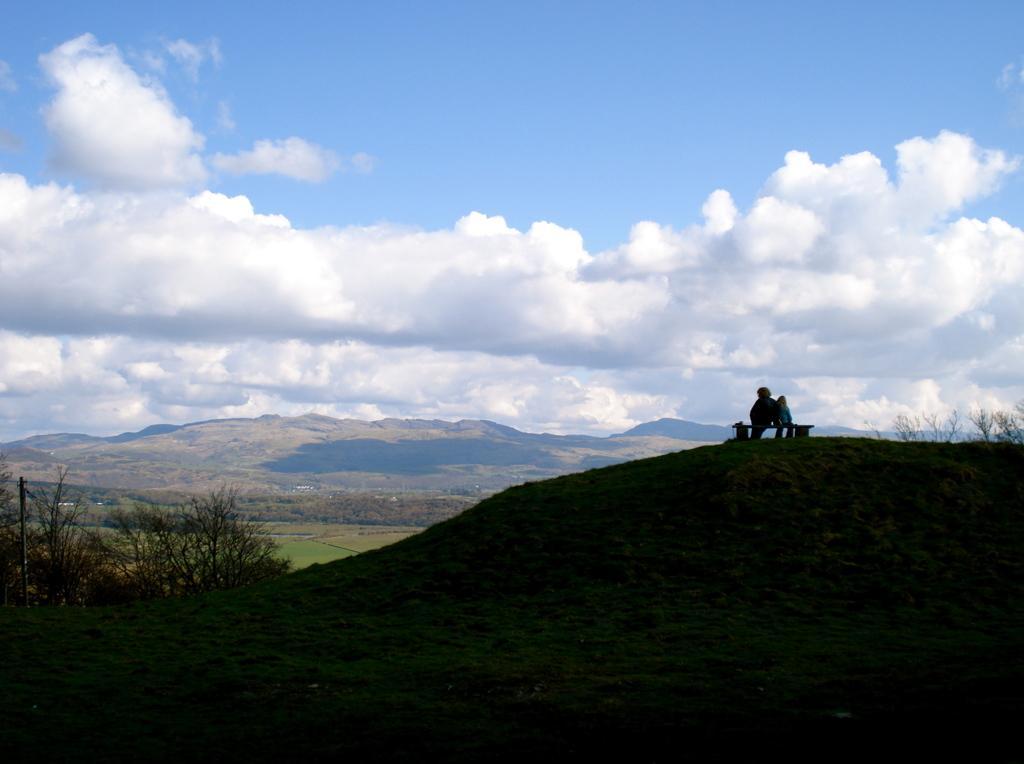Describe this image in one or two sentences. In this image we can see there are plants, grass, mountains and people. In the background we can see cloudy sky. 